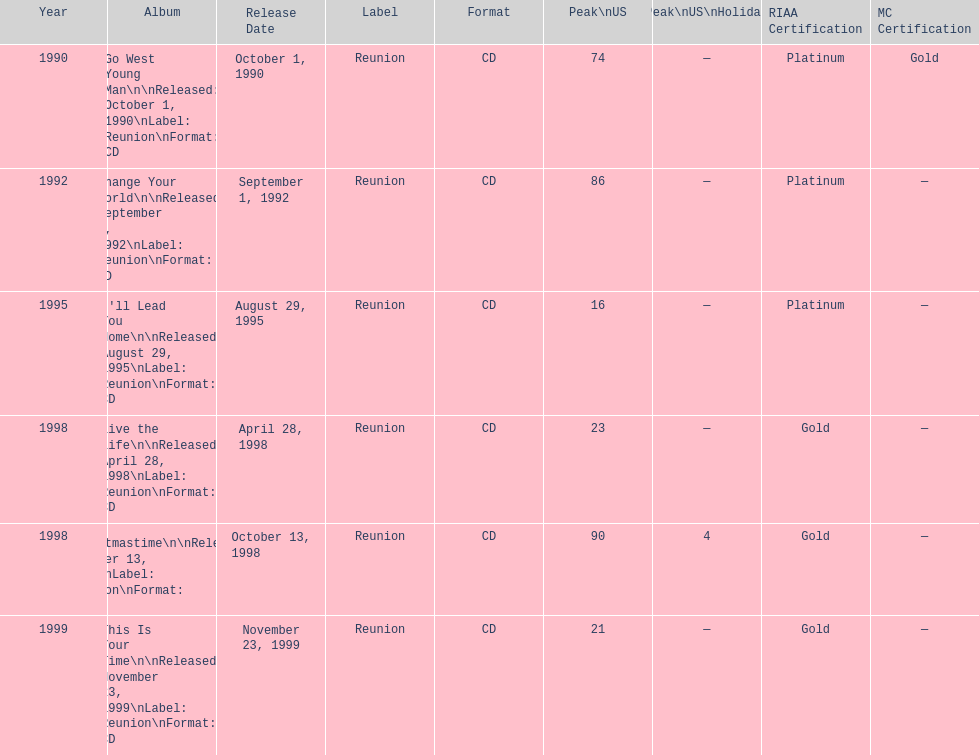Which album has the least peak in the us? I'll Lead You Home. 